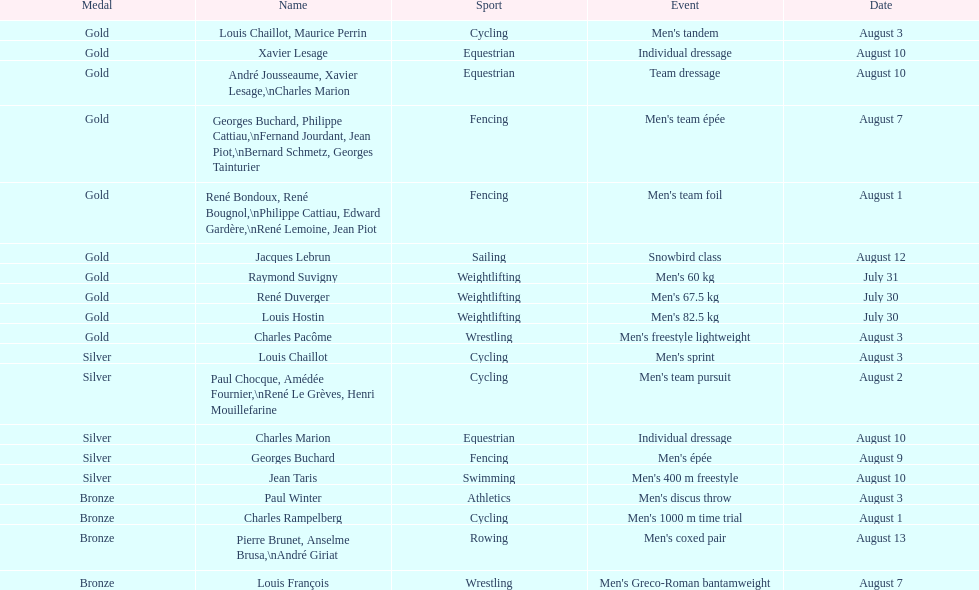What is the subsequent date listed following august 7th? August 1. 